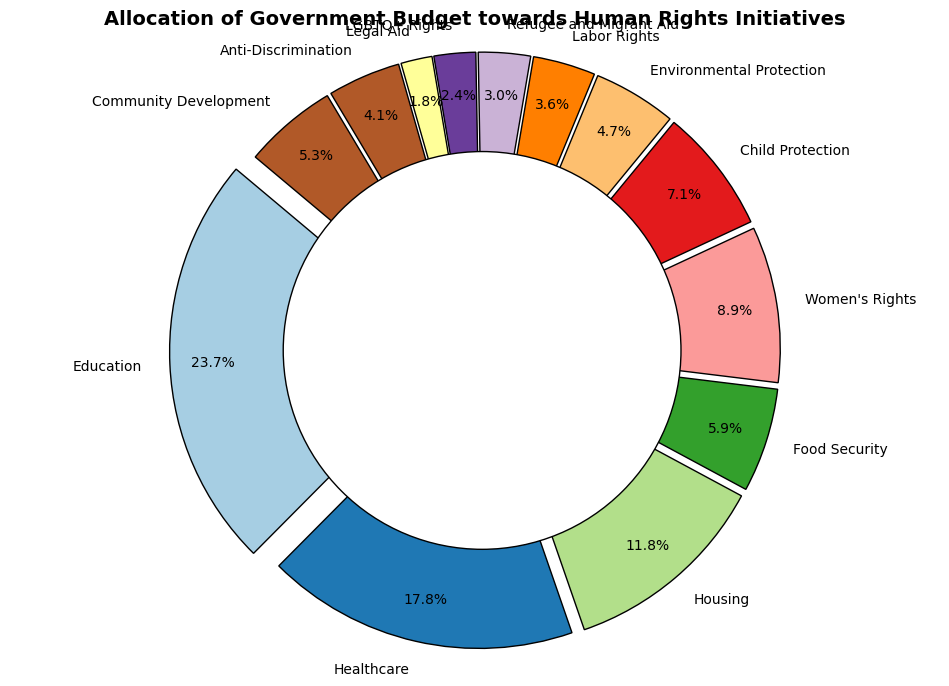What percentage of the total budget is allocated to Education and Healthcare combined? To calculate the combined percentage, first, find the sum of allocations for Education and Healthcare (200 + 150 = 350 million). Next, sum the total allocations across all categories to determine the total budget, which is 845 million. Finally, divide the combined Education and Healthcare allocation by the total budget and multiply by 100 (350 / 845 * 100 ≈ 41.4%).
Answer: 41.4% Which category receives the smallest allocation and what is its percentage? Identify the category with the smallest allocation by visually inspecting the pie chart. The category with the smallest segment is Legal Aid, which has an allocation of 15 million. To find its percentage, divide 15 by the total budget of 845, then multiply by 100 (15 / 845 * 100 ≈ 1.8%).
Answer: Legal Aid, 1.8% How does the allocation for Women's Rights compare to that for Child Protection? Compare the allocation values for Women's Rights (75 million) and Child Protection (60 million) by inspecting the pie chart. Women's Rights has a higher allocation than Child Protection. By calculating the difference, (75 - 60 = 15 million), you can see that Women's Rights is allocated 15 million more than Child Protection.
Answer: Women's Rights receives 15 million more What is the difference between the allocation for Education and the combined allocation of Housing and Food Security? First, find the sum of allocations for Housing and Food Security (100 + 50 = 150 million). Next, subtract this combined allocation from that of Education (200 - 150 = 50 million). The difference is 50 million, with Education having a higher allocation than the combined total of Housing and Food Security.
Answer: 50 million Which categories have allocations greater than or equal to 50 million but less than 100 million? Inspect the pie chart segments and identify categories that meet the specified range. The categories are Housing (100 million), Women's Rights (75 million), Child Protection (60 million), and Food Security (50 million). Therefore, these categories have allocations within the range 50 million to 100 million.
Answer: Housing, Women's Rights, Child Protection, and Food Security What is the combined percentage of the total budget allocated to Labor Rights, Refugee and Migrant Aid, LGBTQ+ Rights, and Legal Aid? First, sum the allocations of the specified categories (30 + 25 + 20 + 15 = 90 million). Then divide this combined allocation by the total budget (845 million), and multiply by 100 to get the percentage (90 / 845 * 100 ≈ 10.7%).
Answer: 10.7% Among Community Development, Environmental Protection, and Anti-Discrimination, which category receives the highest allocation and by how much? Compare the allocation values for Community Development (45 million), Environmental Protection (40 million), and Anti-Discrimination (35 million) from the pie chart. Community Development receives the highest allocation. To find the difference between Community Development and the next highest allocation, subtract the second-highest allocation from Community Development (45 - 40 = 5 million).
Answer: Community Development, 5 million What is the visual difference between the segment representing Healthcare and the segment representing LGBTQ+ Rights? Examine the pie chart and note that the segment for Healthcare is significantly larger than the segment for LGBTQ+ Rights. This visual difference corresponds to a numerical difference in allocation, with Healthcare receiving 150 million and LGBTQ+ Rights receiving 20 million. The difference in allocation is (150 - 20 = 130 million).
Answer: Healthcare segment is much larger, 130 million difference Which categories have similar-sized segments, suggesting near-equal allocations? By visually inspecting the pie chart, identify segments of similar size. Categories that appear nearly equal are Environmental Protection (40 million) and Labor Rights (30 million) due to their small and similar-sized segments. Though not exactly equal, they are among the closest in size.
Answer: Environmental Protection and Labor Rights 